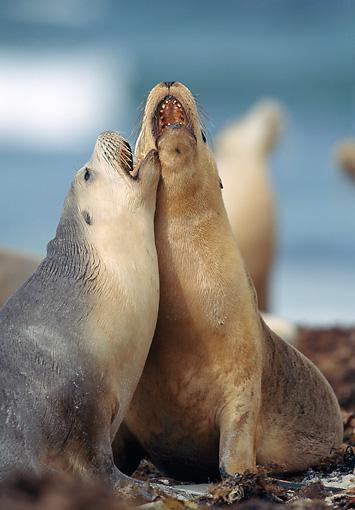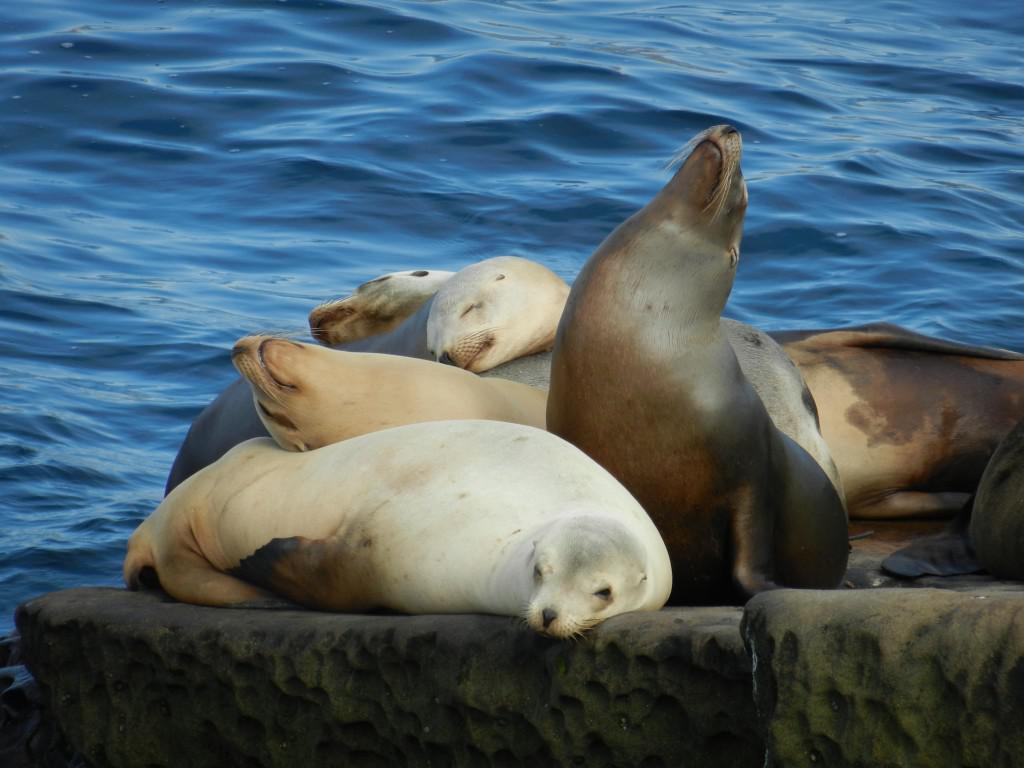The first image is the image on the left, the second image is the image on the right. For the images displayed, is the sentence "Right image shows multiple seals on a rock, and no seals have opened mouths." factually correct? Answer yes or no. Yes. 